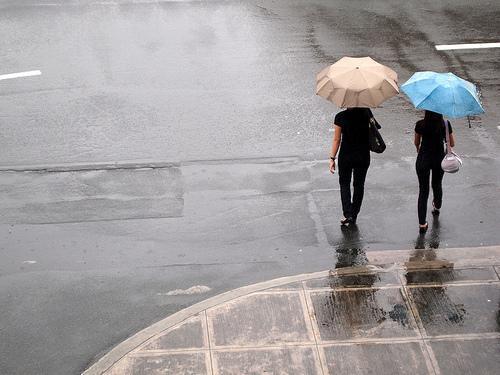How many people are there?
Give a very brief answer. 2. How many people are using a blue umbrella?
Give a very brief answer. 1. 